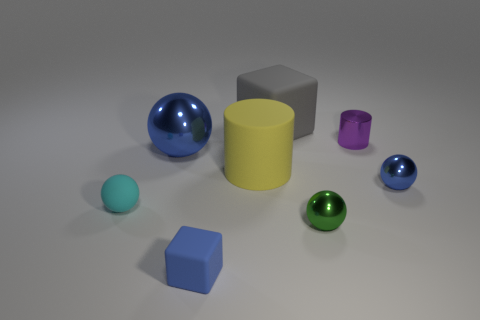What is the shape of the blue thing that is on the left side of the thing that is in front of the small green metallic sphere?
Your answer should be very brief. Sphere. The blue object that is the same size as the gray rubber cube is what shape?
Keep it short and to the point. Sphere. Is there a tiny metal thing that has the same color as the small metallic cylinder?
Give a very brief answer. No. Is the number of blue metallic spheres that are on the right side of the large blue thing the same as the number of tiny green spheres behind the gray rubber cube?
Offer a terse response. No. Does the tiny purple thing have the same shape as the small object to the left of the tiny matte cube?
Your answer should be very brief. No. How many other objects are there of the same material as the cyan object?
Your answer should be compact. 3. There is a purple object; are there any big blue spheres to the right of it?
Offer a terse response. No. Do the green sphere and the yellow rubber object on the right side of the large sphere have the same size?
Offer a very short reply. No. There is a big matte thing in front of the rubber cube that is behind the small blue sphere; what is its color?
Offer a very short reply. Yellow. Do the rubber ball and the green metal sphere have the same size?
Your response must be concise. Yes. 